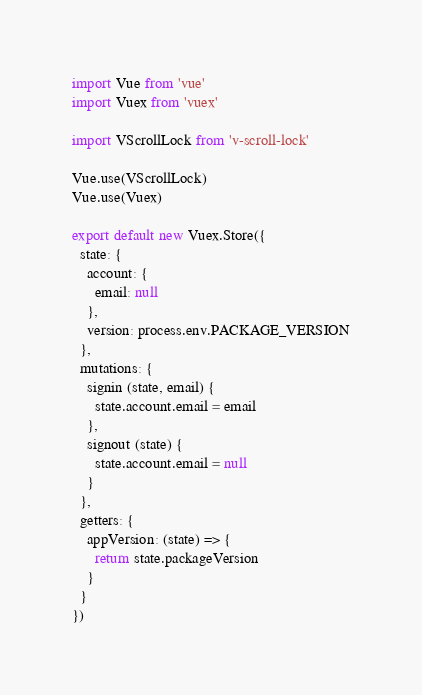Convert code to text. <code><loc_0><loc_0><loc_500><loc_500><_JavaScript_>import Vue from 'vue'
import Vuex from 'vuex'

import VScrollLock from 'v-scroll-lock'

Vue.use(VScrollLock)
Vue.use(Vuex)

export default new Vuex.Store({
  state: {
    account: {
      email: null
    },
    version: process.env.PACKAGE_VERSION
  },
  mutations: {
    signin (state, email) {
      state.account.email = email
    },
    signout (state) {
      state.account.email = null
    }
  },
  getters: {
    appVersion: (state) => {
      return state.packageVersion
    }
  }
})
</code> 